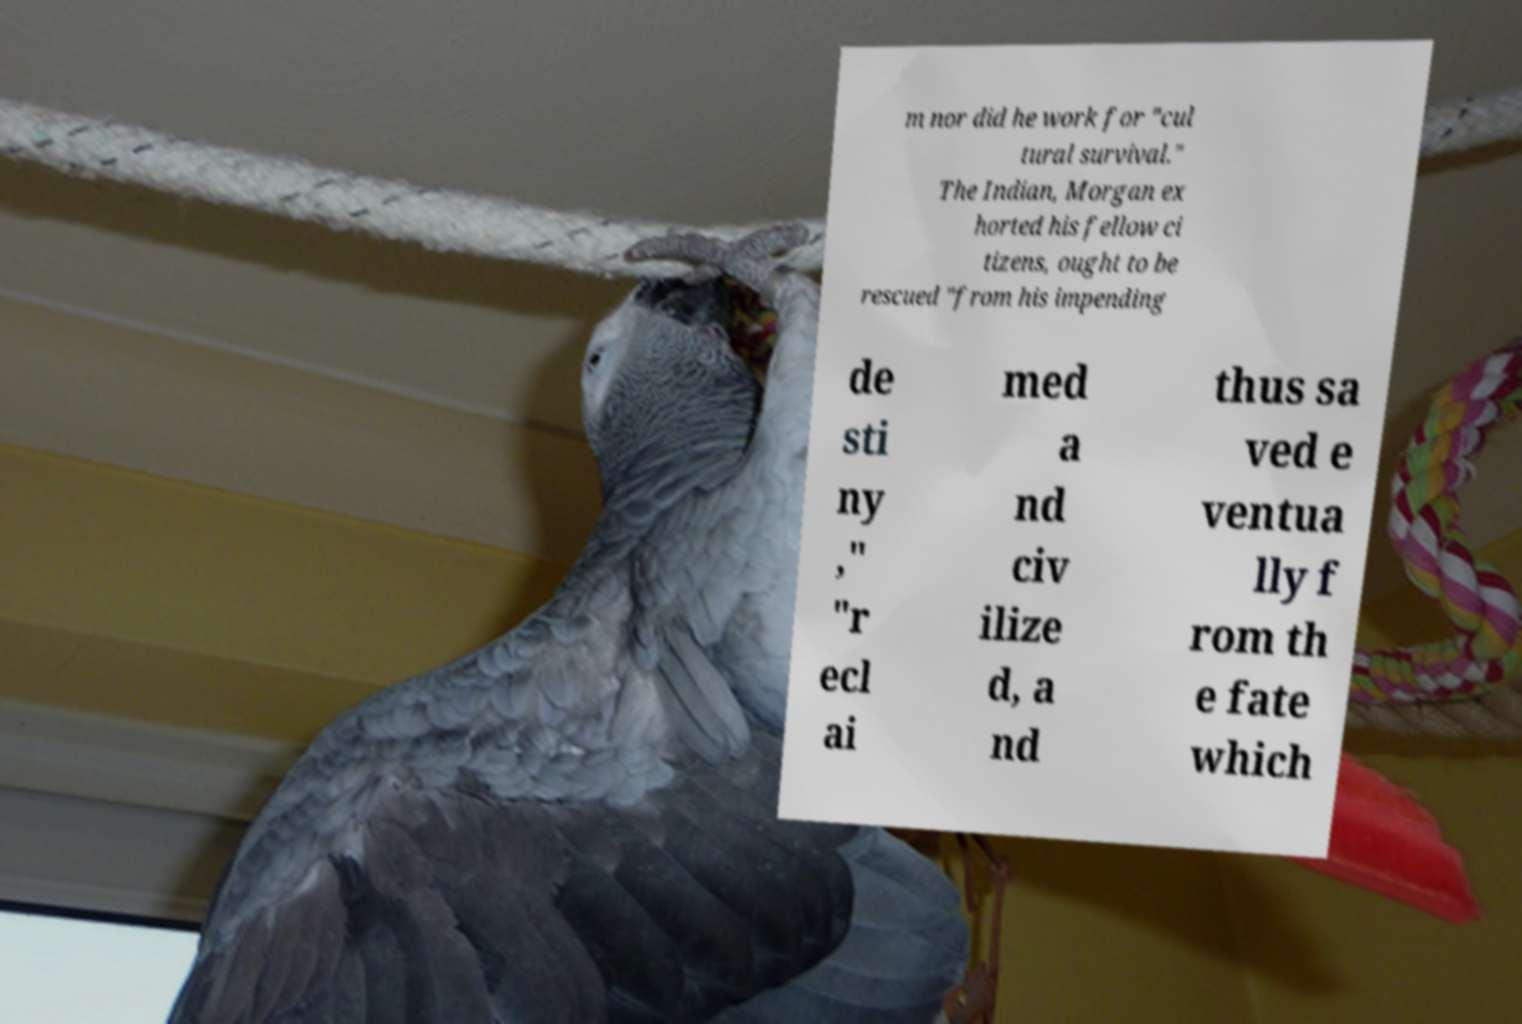Please identify and transcribe the text found in this image. m nor did he work for "cul tural survival." The Indian, Morgan ex horted his fellow ci tizens, ought to be rescued "from his impending de sti ny ," "r ecl ai med a nd civ ilize d, a nd thus sa ved e ventua lly f rom th e fate which 